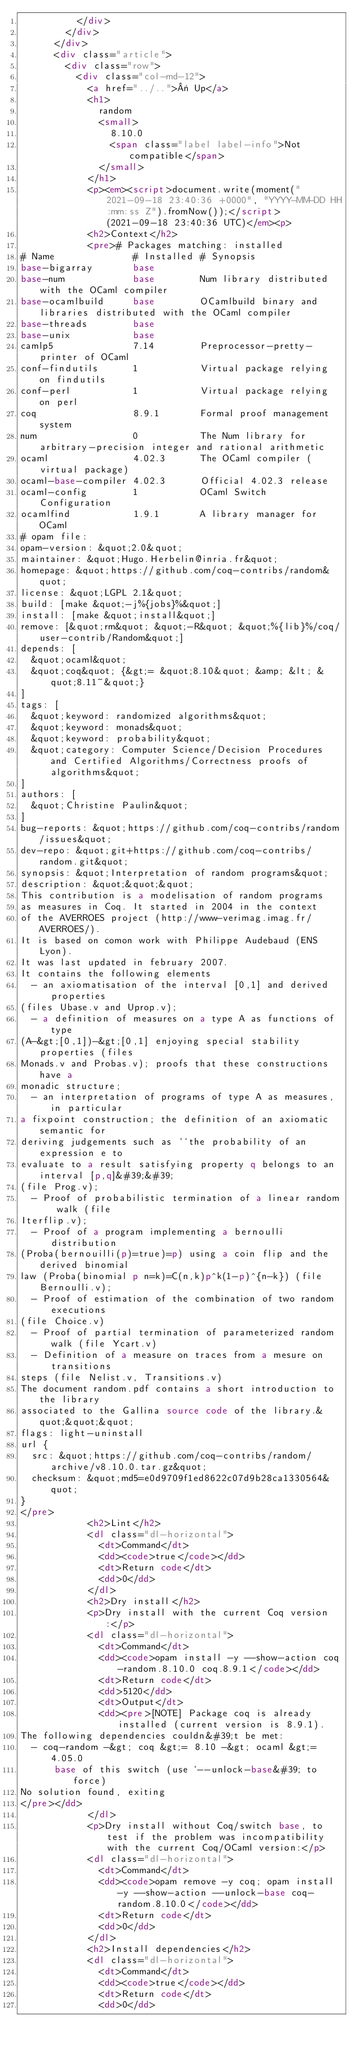Convert code to text. <code><loc_0><loc_0><loc_500><loc_500><_HTML_>          </div>
        </div>
      </div>
      <div class="article">
        <div class="row">
          <div class="col-md-12">
            <a href="../..">« Up</a>
            <h1>
              random
              <small>
                8.10.0
                <span class="label label-info">Not compatible</span>
              </small>
            </h1>
            <p><em><script>document.write(moment("2021-09-18 23:40:36 +0000", "YYYY-MM-DD HH:mm:ss Z").fromNow());</script> (2021-09-18 23:40:36 UTC)</em><p>
            <h2>Context</h2>
            <pre># Packages matching: installed
# Name              # Installed # Synopsis
base-bigarray       base
base-num            base        Num library distributed with the OCaml compiler
base-ocamlbuild     base        OCamlbuild binary and libraries distributed with the OCaml compiler
base-threads        base
base-unix           base
camlp5              7.14        Preprocessor-pretty-printer of OCaml
conf-findutils      1           Virtual package relying on findutils
conf-perl           1           Virtual package relying on perl
coq                 8.9.1       Formal proof management system
num                 0           The Num library for arbitrary-precision integer and rational arithmetic
ocaml               4.02.3      The OCaml compiler (virtual package)
ocaml-base-compiler 4.02.3      Official 4.02.3 release
ocaml-config        1           OCaml Switch Configuration
ocamlfind           1.9.1       A library manager for OCaml
# opam file:
opam-version: &quot;2.0&quot;
maintainer: &quot;Hugo.Herbelin@inria.fr&quot;
homepage: &quot;https://github.com/coq-contribs/random&quot;
license: &quot;LGPL 2.1&quot;
build: [make &quot;-j%{jobs}%&quot;]
install: [make &quot;install&quot;]
remove: [&quot;rm&quot; &quot;-R&quot; &quot;%{lib}%/coq/user-contrib/Random&quot;]
depends: [
  &quot;ocaml&quot;
  &quot;coq&quot; {&gt;= &quot;8.10&quot; &amp; &lt; &quot;8.11~&quot;}
]
tags: [
  &quot;keyword: randomized algorithms&quot;
  &quot;keyword: monads&quot;
  &quot;keyword: probability&quot;
  &quot;category: Computer Science/Decision Procedures and Certified Algorithms/Correctness proofs of algorithms&quot;
]
authors: [
  &quot;Christine Paulin&quot;
]
bug-reports: &quot;https://github.com/coq-contribs/random/issues&quot;
dev-repo: &quot;git+https://github.com/coq-contribs/random.git&quot;
synopsis: &quot;Interpretation of random programs&quot;
description: &quot;&quot;&quot;
This contribution is a modelisation of random programs
as measures in Coq. It started in 2004 in the context
of the AVERROES project (http://www-verimag.imag.fr/AVERROES/).
It is based on comon work with Philippe Audebaud (ENS Lyon).
It was last updated in february 2007.
It contains the following elements
  - an axiomatisation of the interval [0,1] and derived properties
(files Ubase.v and Uprop.v);
  - a definition of measures on a type A as functions of type
(A-&gt;[0,1])-&gt;[0,1] enjoying special stability properties (files
Monads.v and Probas.v); proofs that these constructions have a
monadic structure;
  - an interpretation of programs of type A as measures, in particular
a fixpoint construction; the definition of an axiomatic semantic for
deriving judgements such as ``the probability of an expression e to
evaluate to a result satisfying property q belongs to an interval [p,q]&#39;&#39;
(file Prog.v);
  - Proof of probabilistic termination of a linear random walk (file
Iterflip.v);
  - Proof of a program implementing a bernoulli distribution
(Proba(bernouilli(p)=true)=p) using a coin flip and the derived binomial
law (Proba(binomial p n=k)=C(n,k)p^k(1-p)^{n-k}) (file Bernoulli.v);
  - Proof of estimation of the combination of two random executions
(file Choice.v)
  - Proof of partial termination of parameterized random walk (file Ycart.v)
  - Definition of a measure on traces from a mesure on transitions
steps (file Nelist.v, Transitions.v)
The document random.pdf contains a short introduction to the library
associated to the Gallina source code of the library.&quot;&quot;&quot;
flags: light-uninstall
url {
  src: &quot;https://github.com/coq-contribs/random/archive/v8.10.0.tar.gz&quot;
  checksum: &quot;md5=e0d9709f1ed8622c07d9b28ca1330564&quot;
}
</pre>
            <h2>Lint</h2>
            <dl class="dl-horizontal">
              <dt>Command</dt>
              <dd><code>true</code></dd>
              <dt>Return code</dt>
              <dd>0</dd>
            </dl>
            <h2>Dry install</h2>
            <p>Dry install with the current Coq version:</p>
            <dl class="dl-horizontal">
              <dt>Command</dt>
              <dd><code>opam install -y --show-action coq-random.8.10.0 coq.8.9.1</code></dd>
              <dt>Return code</dt>
              <dd>5120</dd>
              <dt>Output</dt>
              <dd><pre>[NOTE] Package coq is already installed (current version is 8.9.1).
The following dependencies couldn&#39;t be met:
  - coq-random -&gt; coq &gt;= 8.10 -&gt; ocaml &gt;= 4.05.0
      base of this switch (use `--unlock-base&#39; to force)
No solution found, exiting
</pre></dd>
            </dl>
            <p>Dry install without Coq/switch base, to test if the problem was incompatibility with the current Coq/OCaml version:</p>
            <dl class="dl-horizontal">
              <dt>Command</dt>
              <dd><code>opam remove -y coq; opam install -y --show-action --unlock-base coq-random.8.10.0</code></dd>
              <dt>Return code</dt>
              <dd>0</dd>
            </dl>
            <h2>Install dependencies</h2>
            <dl class="dl-horizontal">
              <dt>Command</dt>
              <dd><code>true</code></dd>
              <dt>Return code</dt>
              <dd>0</dd></code> 